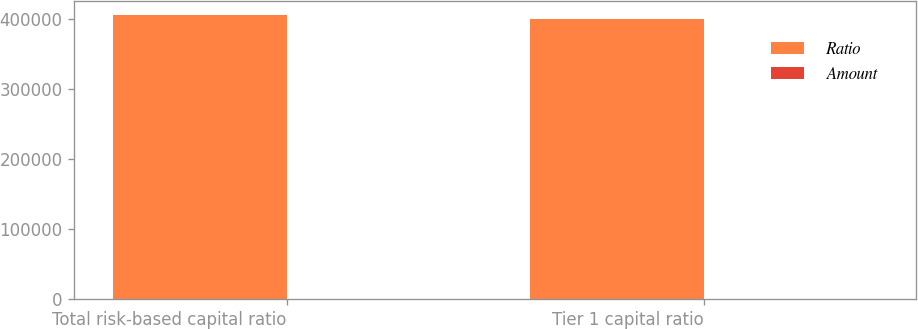Convert chart to OTSL. <chart><loc_0><loc_0><loc_500><loc_500><stacked_bar_chart><ecel><fcel>Total risk-based capital ratio<fcel>Tier 1 capital ratio<nl><fcel>Ratio<fcel>405000<fcel>399187<nl><fcel>Amount<fcel>92.5<fcel>22.8<nl></chart> 